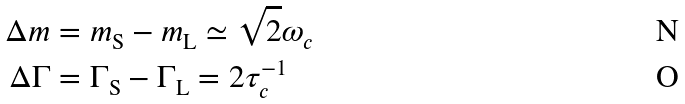Convert formula to latex. <formula><loc_0><loc_0><loc_500><loc_500>\Delta m & = m _ { \text {S} } - m _ { \text {L} } \simeq \sqrt { 2 } \omega _ { c } \\ \Delta \Gamma & = \Gamma _ { \text {S} } - \Gamma _ { \text {L} } = 2 \tau _ { c } ^ { - 1 }</formula> 